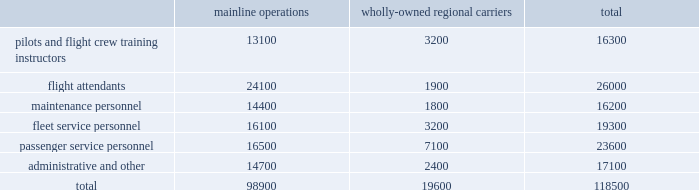Table of contents other areas in which we do business .
Depending on the scope of such regulation , certain of our facilities and operations , or the operations of our suppliers , may be subject to additional operating and other permit requirements , potentially resulting in increased operating costs .
Future regulatory developments future regulatory developments and actions could affect operations and increase operating costs for the airline industry , including our airline subsidiaries .
See part i , item 1a .
Risk factors 2013 201cif we are unable to obtain and maintain adequate facilities and infrastructure throughout our system and , at some airports , adequate slots , we may be unable to operate our existing flight schedule and to expand or change our route network in the future , which may have a material adverse impact on our operations , 201d 201cour business is subject to extensive government regulation , which may result in increases in our costs , disruptions to our operations , limits on our operating flexibility , reductions in the demand for air travel , and competitive disadvantages 201d and 201cwe are subject to many forms of environmental regulation and may incur substantial costs as a result 201d for additional information .
Employees and labor relations the airline business is labor intensive .
In 2015 , salaries , wages and benefits were our largest expenses and represented approximately 31% ( 31 % ) of our operating expenses .
The table below presents our approximate number of active full-time equivalent employees as of december 31 , 2015 .
Mainline operations wholly-owned regional carriers total .

What percentage of total active full-time equivalent employees consisted of passenger service personnel? 
Computations: (23600 / 118500)
Answer: 0.19916. Table of contents other areas in which we do business .
Depending on the scope of such regulation , certain of our facilities and operations , or the operations of our suppliers , may be subject to additional operating and other permit requirements , potentially resulting in increased operating costs .
Future regulatory developments future regulatory developments and actions could affect operations and increase operating costs for the airline industry , including our airline subsidiaries .
See part i , item 1a .
Risk factors 2013 201cif we are unable to obtain and maintain adequate facilities and infrastructure throughout our system and , at some airports , adequate slots , we may be unable to operate our existing flight schedule and to expand or change our route network in the future , which may have a material adverse impact on our operations , 201d 201cour business is subject to extensive government regulation , which may result in increases in our costs , disruptions to our operations , limits on our operating flexibility , reductions in the demand for air travel , and competitive disadvantages 201d and 201cwe are subject to many forms of environmental regulation and may incur substantial costs as a result 201d for additional information .
Employees and labor relations the airline business is labor intensive .
In 2015 , salaries , wages and benefits were our largest expenses and represented approximately 31% ( 31 % ) of our operating expenses .
The table below presents our approximate number of active full-time equivalent employees as of december 31 , 2015 .
Mainline operations wholly-owned regional carriers total .

What is the percent of the mainline operations full-time equivalent employees to the total number of full-time equivalent employees? 
Rationale: the percent is amount in question divided by the total amount
Computations: (98900 / 118500)
Answer: 0.8346. Table of contents other areas in which we do business .
Depending on the scope of such regulation , certain of our facilities and operations , or the operations of our suppliers , may be subject to additional operating and other permit requirements , potentially resulting in increased operating costs .
Future regulatory developments future regulatory developments and actions could affect operations and increase operating costs for the airline industry , including our airline subsidiaries .
See part i , item 1a .
Risk factors 2013 201cif we are unable to obtain and maintain adequate facilities and infrastructure throughout our system and , at some airports , adequate slots , we may be unable to operate our existing flight schedule and to expand or change our route network in the future , which may have a material adverse impact on our operations , 201d 201cour business is subject to extensive government regulation , which may result in increases in our costs , disruptions to our operations , limits on our operating flexibility , reductions in the demand for air travel , and competitive disadvantages 201d and 201cwe are subject to many forms of environmental regulation and may incur substantial costs as a result 201d for additional information .
Employees and labor relations the airline business is labor intensive .
In 2015 , salaries , wages and benefits were our largest expenses and represented approximately 31% ( 31 % ) of our operating expenses .
The table below presents our approximate number of active full-time equivalent employees as of december 31 , 2015 .
Mainline operations wholly-owned regional carriers total .

What is the ratio of passenger service personnel to the flight attendants? 
Rationale: for every flight attendant there is 0.91 passenger service personnel
Computations: (23600 / 26000)
Answer: 0.90769. 